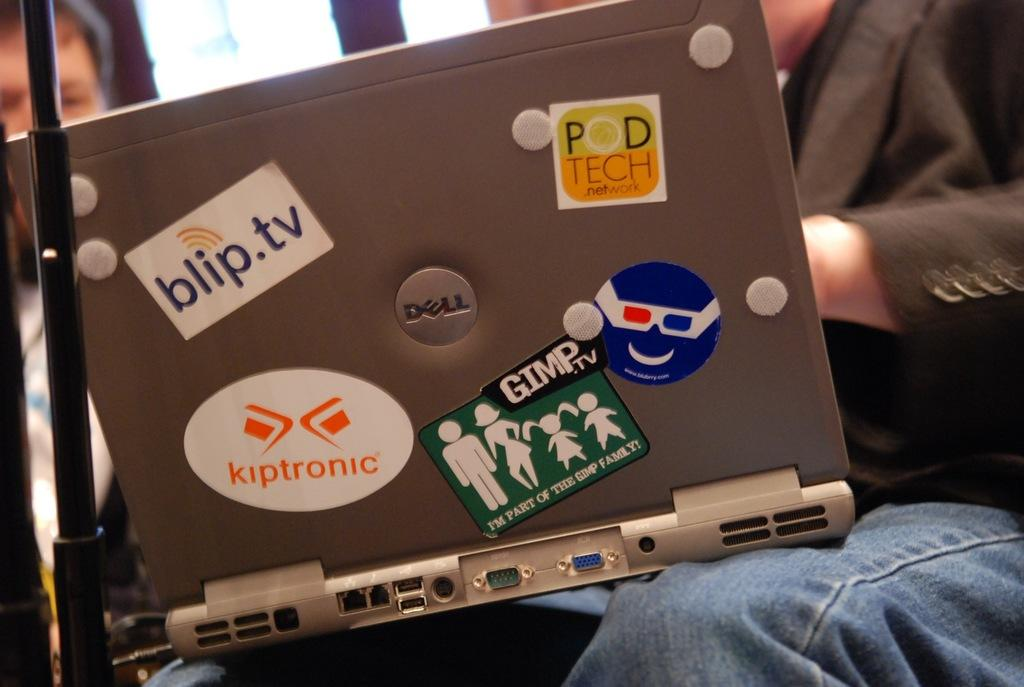What object with stickers on it can be seen in the image? There is a laptop with stickers on it in the image. What is the person doing with the laptop? A person is operating the laptop. Can you describe the other person in the image? There is another person sitting beside the person operating the laptop. What architectural features can be seen in the image? There are poles visible in the image. Can you see any giants walking on the bridge in the image? There is no bridge or giants present in the image. 